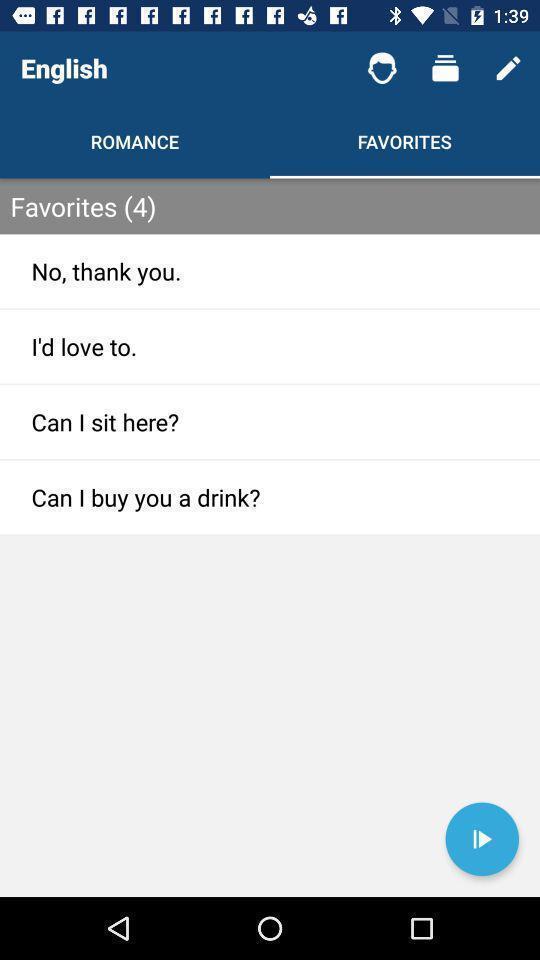Tell me about the visual elements in this screen capture. Showing favorites page of a learning app. 